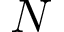<formula> <loc_0><loc_0><loc_500><loc_500>N</formula> 